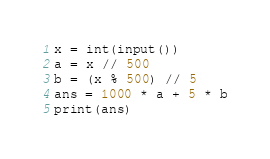<code> <loc_0><loc_0><loc_500><loc_500><_Python_>x = int(input())
a = x // 500
b = (x % 500) // 5
ans = 1000 * a + 5 * b
print(ans)</code> 